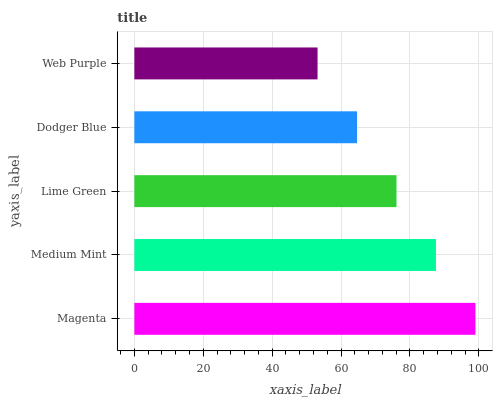Is Web Purple the minimum?
Answer yes or no. Yes. Is Magenta the maximum?
Answer yes or no. Yes. Is Medium Mint the minimum?
Answer yes or no. No. Is Medium Mint the maximum?
Answer yes or no. No. Is Magenta greater than Medium Mint?
Answer yes or no. Yes. Is Medium Mint less than Magenta?
Answer yes or no. Yes. Is Medium Mint greater than Magenta?
Answer yes or no. No. Is Magenta less than Medium Mint?
Answer yes or no. No. Is Lime Green the high median?
Answer yes or no. Yes. Is Lime Green the low median?
Answer yes or no. Yes. Is Magenta the high median?
Answer yes or no. No. Is Web Purple the low median?
Answer yes or no. No. 